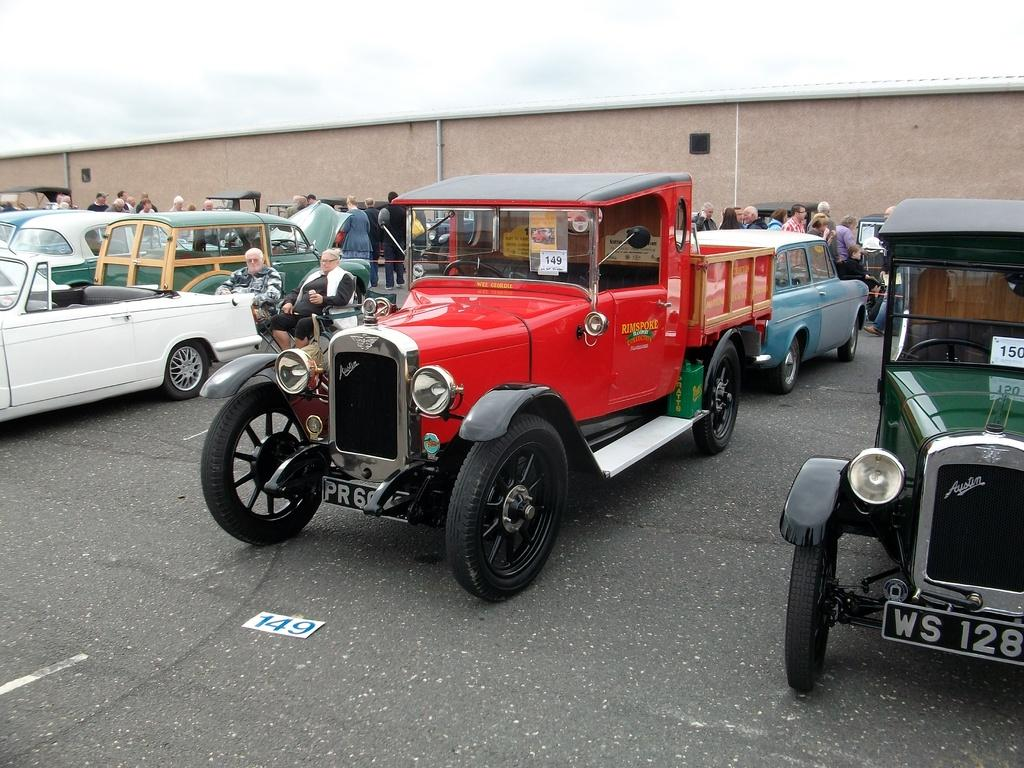What can be seen on the road in the image? There are vehicles parked on the road in the image. What else is present in the image besides the parked vehicles? There are people around the vehicles in the image. Can you describe the large compartment visible in the background of the image? Unfortunately, the facts provided do not give any information about the large compartment in the background. What type of square is being regretted by the industry in the image? There is no square, industry, or regret present in the image. 